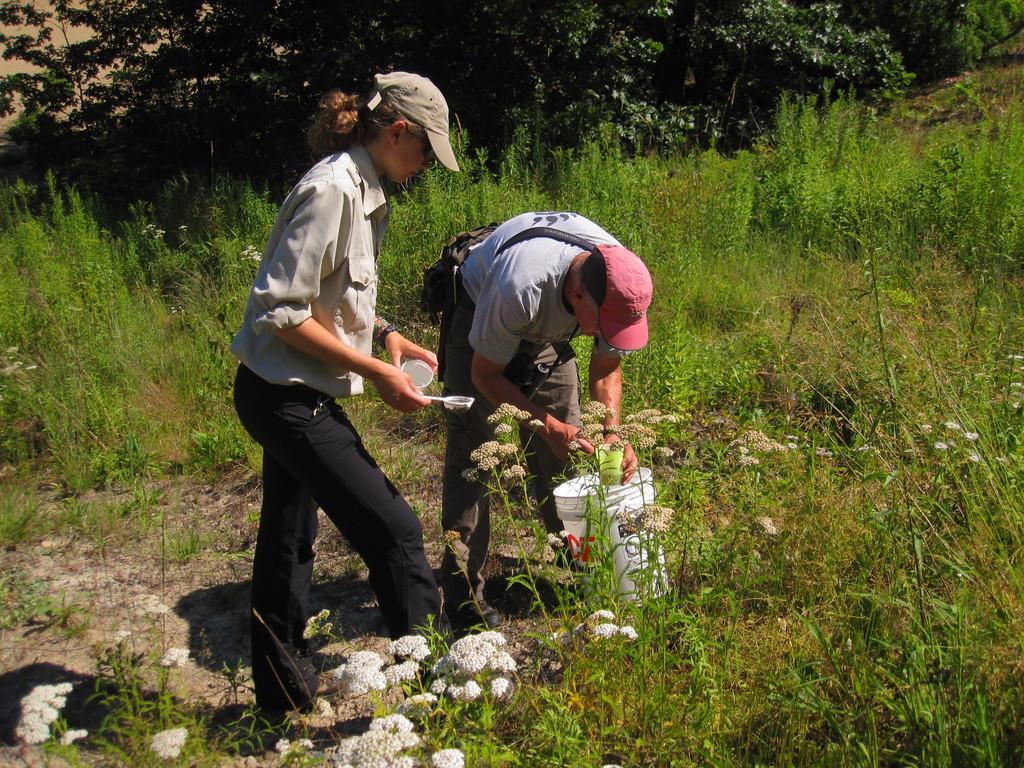Describe this image in one or two sentences. In the middle of the picture, we see two people are standing. The man is holding a green color glass in his hands. Beside him, we see a white bucket. The woman is also holding a spoon and a white glass in her hands. At the bottom of the picture, we see the plants which have flowers. These flowers are in white color. In the background, there are plants and trees. 